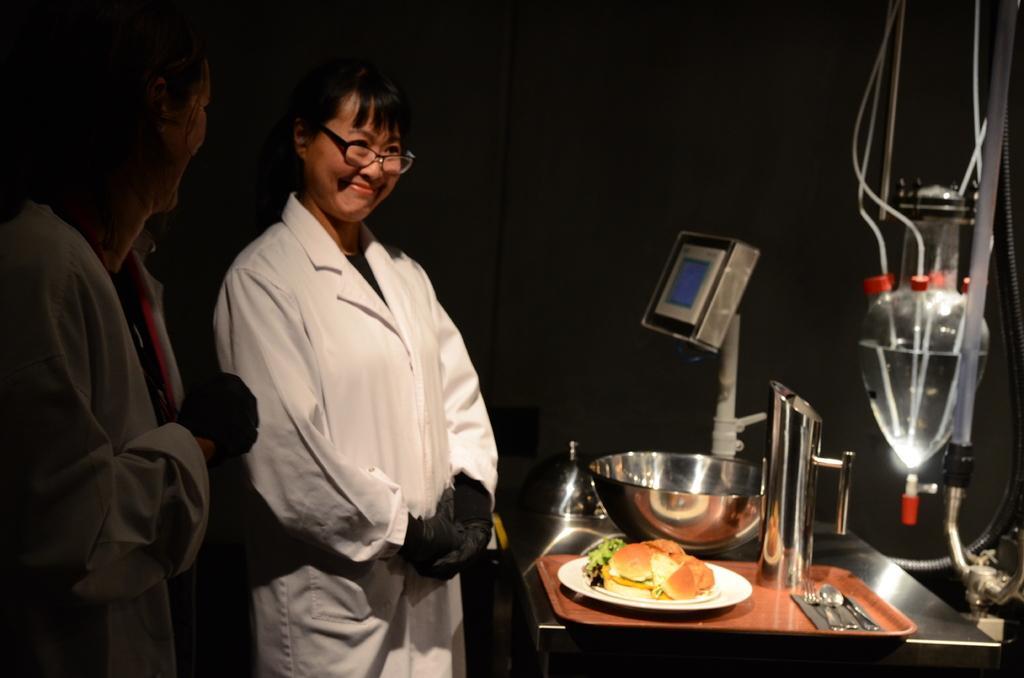In one or two sentences, can you explain what this image depicts? In the image on the left side,we can see two persons were standing and they were smiling,which we can see on their faces. In front of them,there is a table. On the table,we can see plates,spoons,some food items,mug,bowl and few other objects. 